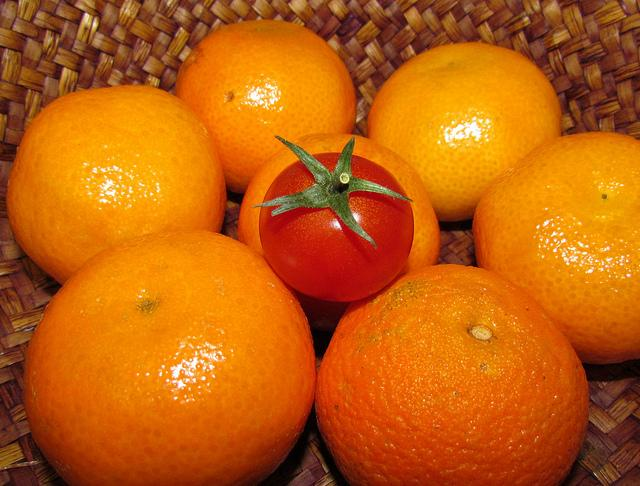What vegetable is shown in the picture? Please explain your reasoning. tomato. The red vegetable is a tomatoe as shown. 